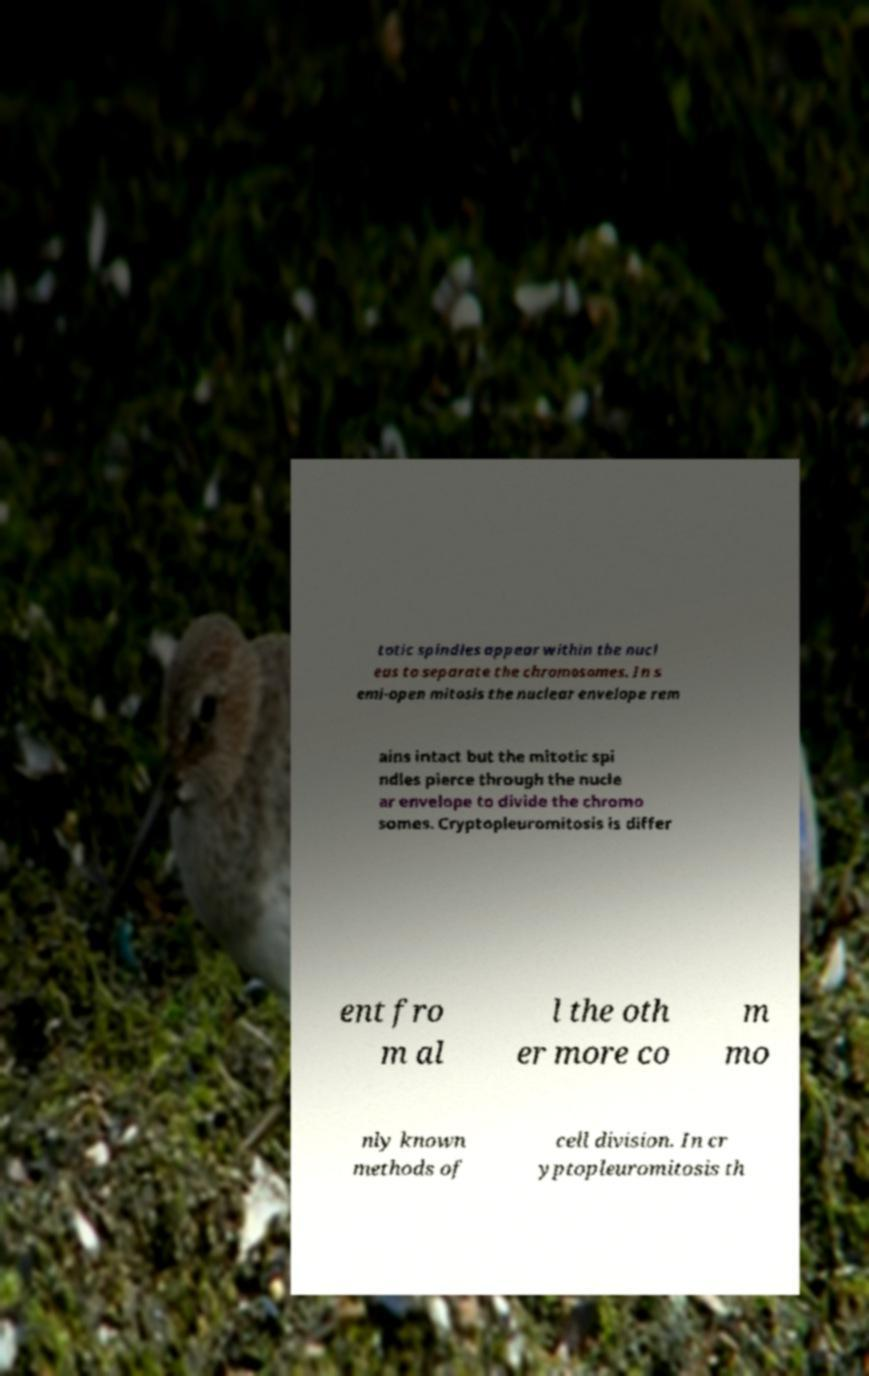Can you read and provide the text displayed in the image?This photo seems to have some interesting text. Can you extract and type it out for me? totic spindles appear within the nucl eus to separate the chromosomes. In s emi-open mitosis the nuclear envelope rem ains intact but the mitotic spi ndles pierce through the nucle ar envelope to divide the chromo somes. Cryptopleuromitosis is differ ent fro m al l the oth er more co m mo nly known methods of cell division. In cr yptopleuromitosis th 